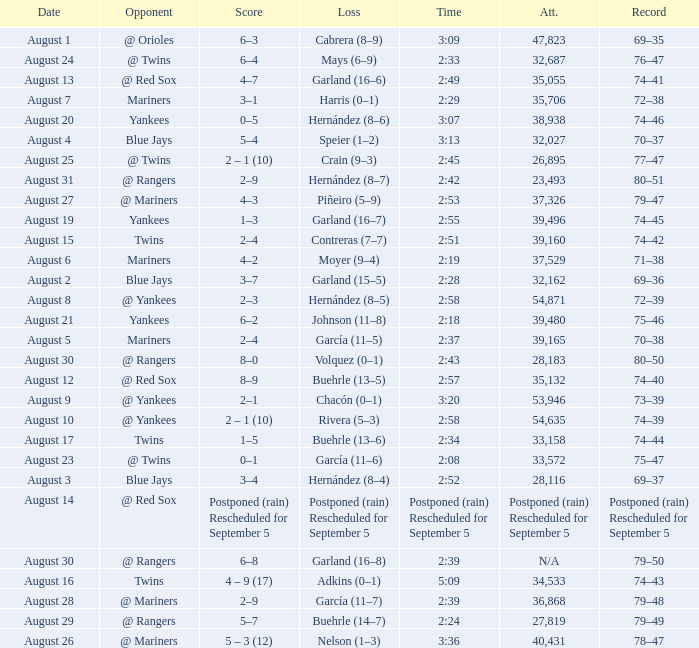Who lost on August 27? Piñeiro (5–9). 